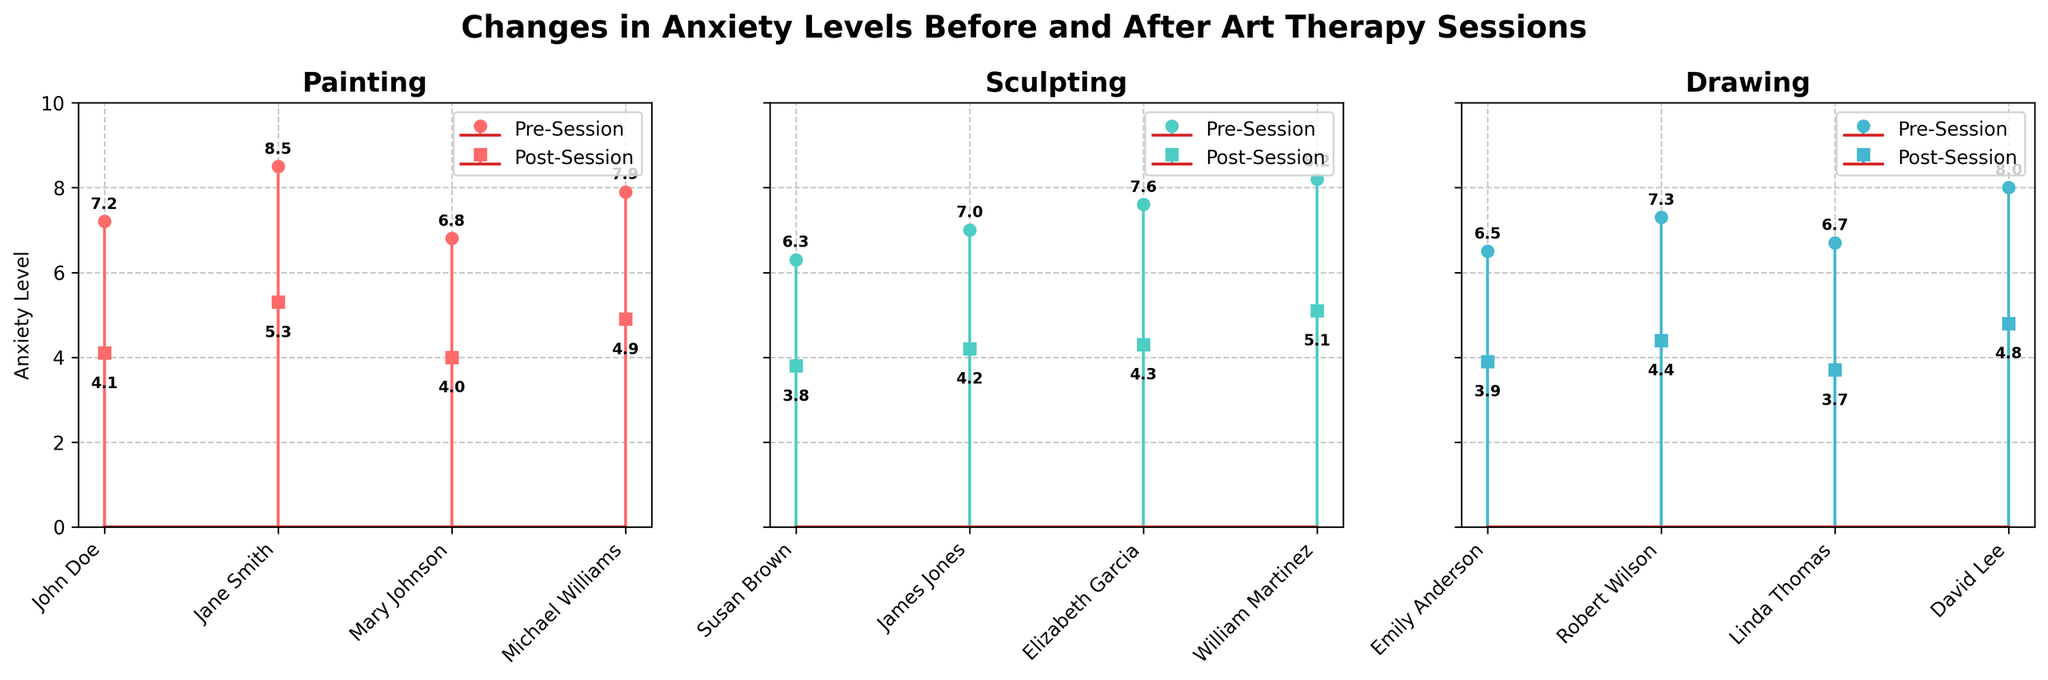What is the title of the figure? The title is displayed at the top of the figure. It reads, "Changes in Anxiety Levels Before and After Art Therapy Sessions."
Answer: Changes in Anxiety Levels Before and After Art Therapy Sessions Which medium has the highest pre-session anxiety level? In the Painting subplot, Jane Smith has a pre-session anxiety level of 8.5, which is the highest among all participants in any medium.
Answer: Painting How many participants are shown for each medium? The x-axis in each subplot represents participants, and there are 4 markers on the x-axis for each medium. Therefore, each medium has 4 participants.
Answer: 4 Which participant experienced the greatest reduction in anxiety after art therapy sessions? The reduction can be calculated by subtracting post-session values from pre-session values for each participant. Michael Williams (Painting) experienced the greatest reduction: 7.9 - 4.9 = 3.0.
Answer: Michael Williams What are the colors used to represent Pre- and Post-Session anxiety levels? By observing the lines and markers in each subplot: Pre-Session levels are represented by lines and 'o' markers, Post-Session levels are represented by lines and 's' markers. The colors are red for Painting, teal for Sculpting, and blue for Drawing.
Answer: Red, Teal, Blue Which medium shows the lowest average post-session anxiety level? Calculate the average of the post-session anxiety levels for each medium: Painting: (4.1 + 5.3 + 4.0 + 4.9)/4 = 4.575, Sculpting: (3.8 + 4.2 + 4.3 + 5.1)/4 = 4.35, Drawing: (3.9 + 4.4 + 3.7 + 4.8)/4 = 4.2. Drawing has the lowest average post-session anxiety level.
Answer: Drawing Is there any participant whose anxiety level did not decrease after the art therapy sessions? By observing the stem plots, all participants have lower post-session anxiety levels compared to their pre-session levels, indicating that everyone experienced a decrease in anxiety.
Answer: No What is the average reduction in anxiety levels for the Sculpting medium? Subtract post-session levels from pre-session levels for each participant and take the average: ((6.3-3.8) + (7.0-4.2) + (7.6-4.3) + (8.2-5.1))/4 = (2.5 + 2.8 + 3.3 + 3.1)/4 = 2.925
Answer: 2.925 Which participant in the Drawing medium had the highest pre-session anxiety level? In the Drawing subplot, David Lee has the highest pre-session anxiety level of 8.0.
Answer: David Lee 